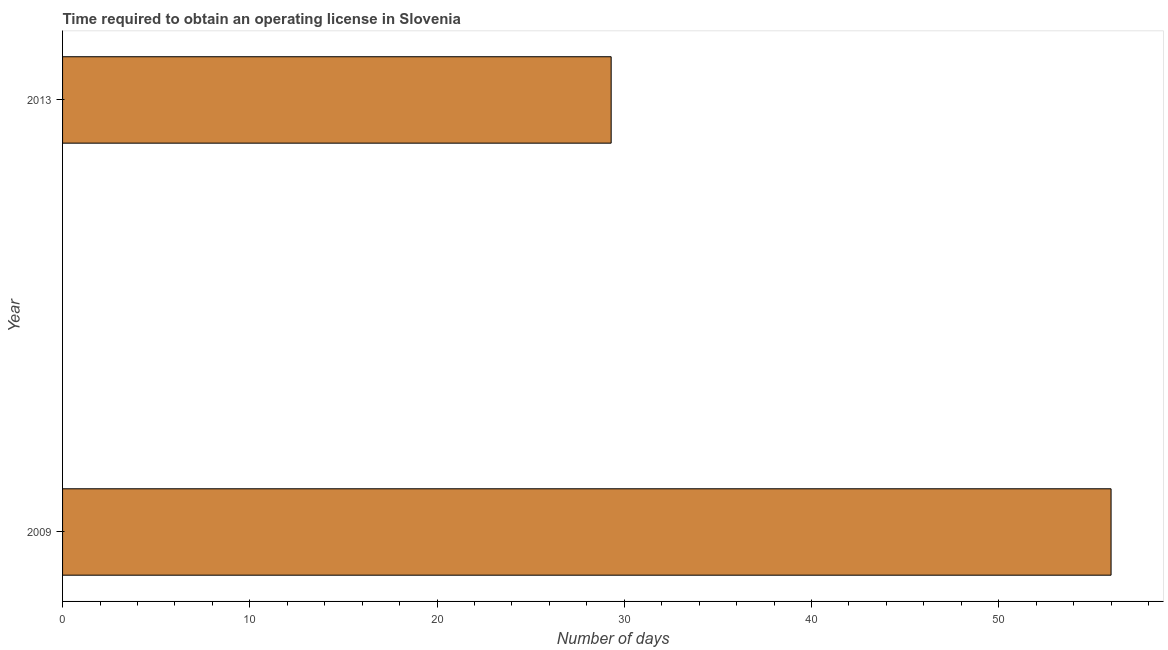Does the graph contain grids?
Offer a terse response. No. What is the title of the graph?
Offer a very short reply. Time required to obtain an operating license in Slovenia. What is the label or title of the X-axis?
Offer a very short reply. Number of days. What is the label or title of the Y-axis?
Your answer should be compact. Year. What is the number of days to obtain operating license in 2013?
Provide a short and direct response. 29.3. Across all years, what is the maximum number of days to obtain operating license?
Your answer should be compact. 56. Across all years, what is the minimum number of days to obtain operating license?
Give a very brief answer. 29.3. What is the sum of the number of days to obtain operating license?
Ensure brevity in your answer.  85.3. What is the difference between the number of days to obtain operating license in 2009 and 2013?
Your response must be concise. 26.7. What is the average number of days to obtain operating license per year?
Your response must be concise. 42.65. What is the median number of days to obtain operating license?
Your answer should be compact. 42.65. What is the ratio of the number of days to obtain operating license in 2009 to that in 2013?
Provide a short and direct response. 1.91. How many bars are there?
Provide a short and direct response. 2. Are all the bars in the graph horizontal?
Your response must be concise. Yes. How many years are there in the graph?
Make the answer very short. 2. What is the difference between two consecutive major ticks on the X-axis?
Your answer should be compact. 10. What is the Number of days in 2009?
Ensure brevity in your answer.  56. What is the Number of days in 2013?
Keep it short and to the point. 29.3. What is the difference between the Number of days in 2009 and 2013?
Your answer should be very brief. 26.7. What is the ratio of the Number of days in 2009 to that in 2013?
Ensure brevity in your answer.  1.91. 